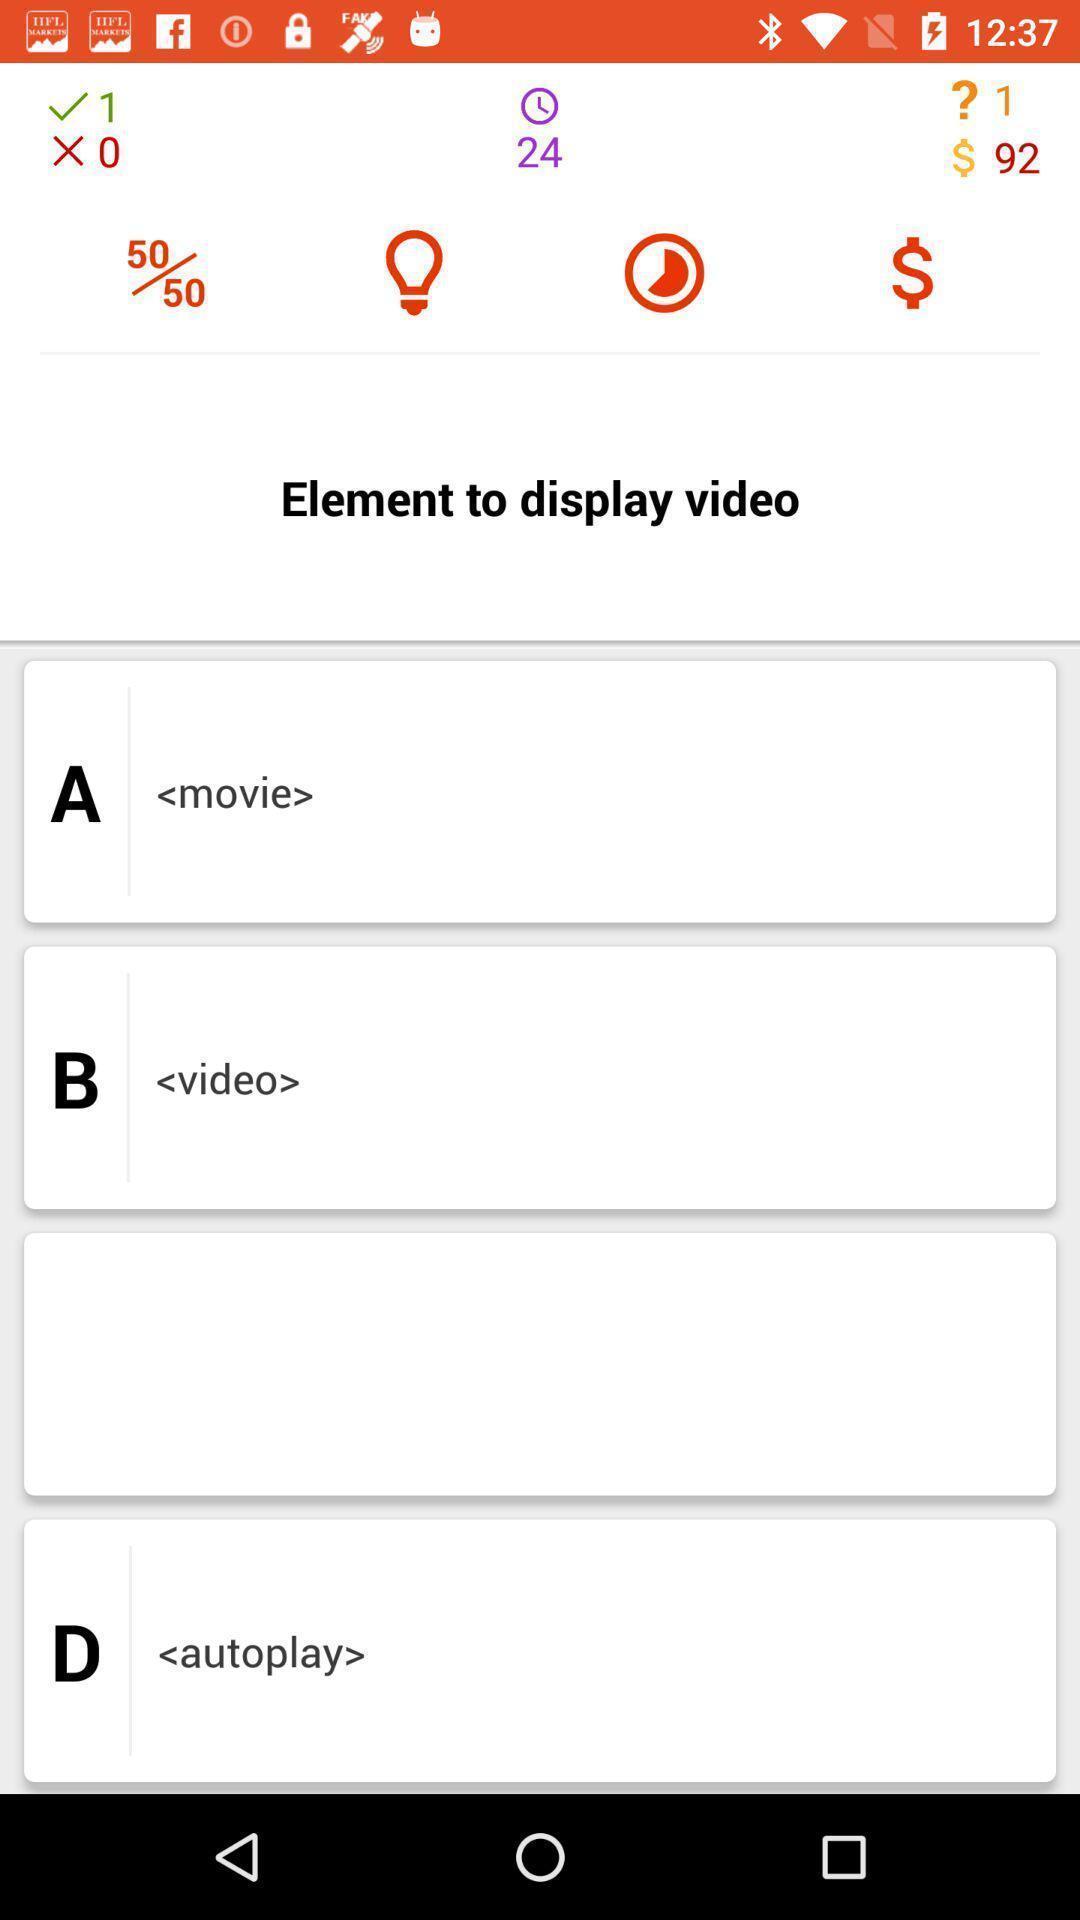Provide a textual representation of this image. Screen shows several display options. 